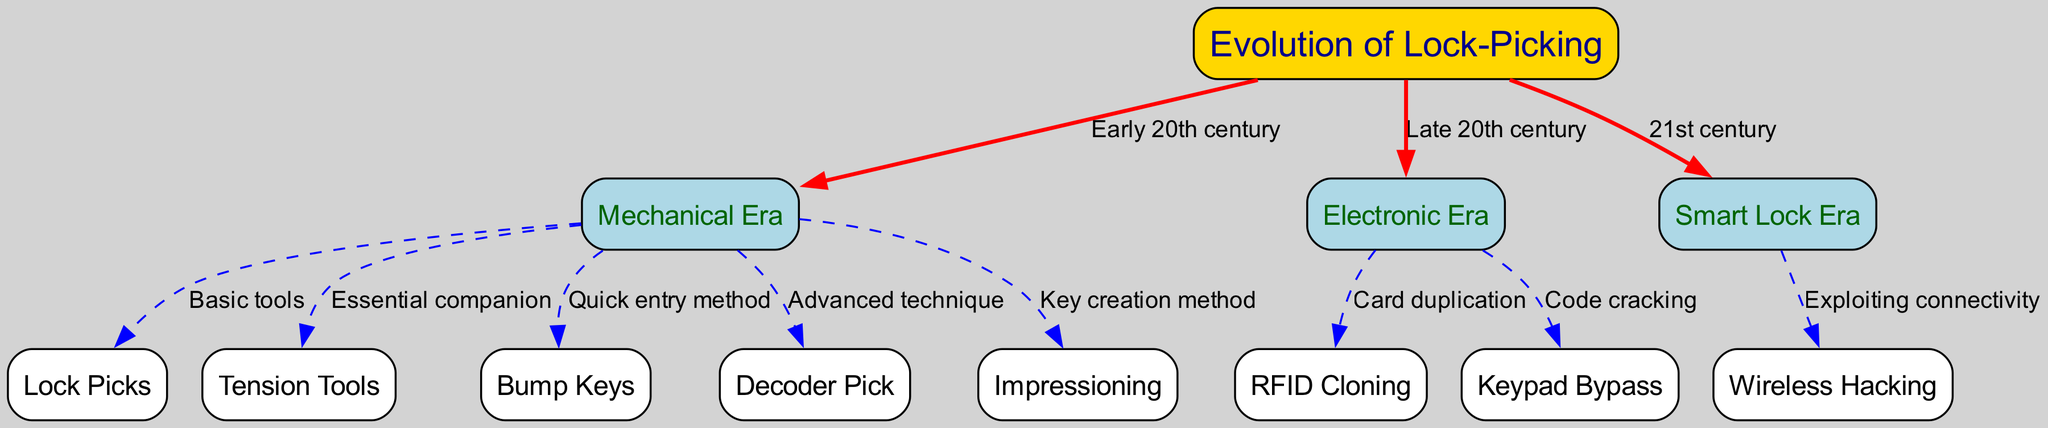What's the total number of nodes in the diagram? The diagram contains a total of 12 distinct nodes, as listed in the data under the "nodes" section.
Answer: 12 Which era introduced 'Smart Lock Era'? The diagram shows that the 'Smart Lock Era' is connected to 'Evolution of Lock-Picking' with the label '21st century', indicating its introduction in that century.
Answer: 21st century What is a notable technique used in the Mechanical Era? In the Mechanical Era, techniques such as 'Bump Keys' are listed as a quick entry method, making it notable within this era.
Answer: Bump Keys How do 'RFID Cloning' and 'Keypad Bypass' relate to the Electronic Era? Both 'RFID Cloning' and 'Keypad Bypass' are directly connected to 'Electronic Era', showing they are techniques developed during this phase of lock-picking evolution.
Answer: Electronic Era Which tool is essential for Mechanical lock-picking? The 'Tension Tools' node is connected to the 'Mechanical Era' and is described as an essential companion, indicating its importance in this era's techniques.
Answer: Tension Tools What type of hacking is associated with the Smart Lock Era? The diagram shows that 'Wireless Hacking' is linked to the 'Smart Lock Era', indicating that it is the type of hacking characteristic of this era.
Answer: Wireless Hacking In what way does 'Impressioning' function in the Mechanical Era? 'Impressioning' is connected to the 'Mechanical Era' with the label 'Key creation method', revealing its function as a technique for generating keys.
Answer: Key creation method What distinguishes the 'Decoder Pick' in the Mechanical Era? The 'Decoder Pick' node is described in connection with the 'Mechanical Era' as an 'Advanced technique', highlighting its sophisticated nature compared to other methods.
Answer: Advanced technique What connects 'Electronic Era' and 'Keypad Bypass'? 'Keypad Bypass' is directly connected to the 'Electronic Era', showing that it is a method developed specifically for this technological phase.
Answer: Electronic Era 